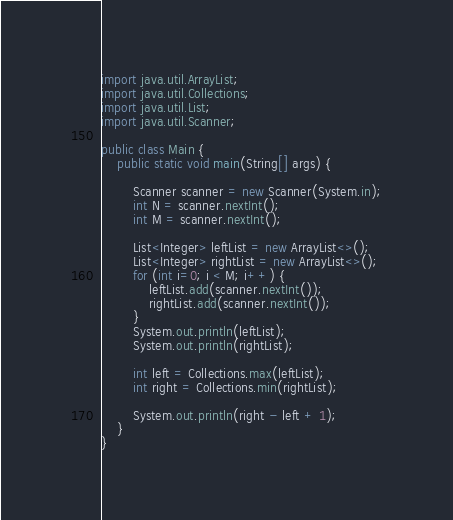<code> <loc_0><loc_0><loc_500><loc_500><_Java_>
import java.util.ArrayList;
import java.util.Collections;
import java.util.List;
import java.util.Scanner;

public class Main {
    public static void main(String[] args) {

        Scanner scanner = new Scanner(System.in);
        int N = scanner.nextInt();
        int M = scanner.nextInt();

        List<Integer> leftList = new ArrayList<>();
        List<Integer> rightList = new ArrayList<>();
        for (int i=0; i < M; i++) {
            leftList.add(scanner.nextInt());
            rightList.add(scanner.nextInt());
        }
        System.out.println(leftList);
        System.out.println(rightList);

        int left = Collections.max(leftList);
        int right = Collections.min(rightList);

        System.out.println(right - left + 1);
    }
}</code> 